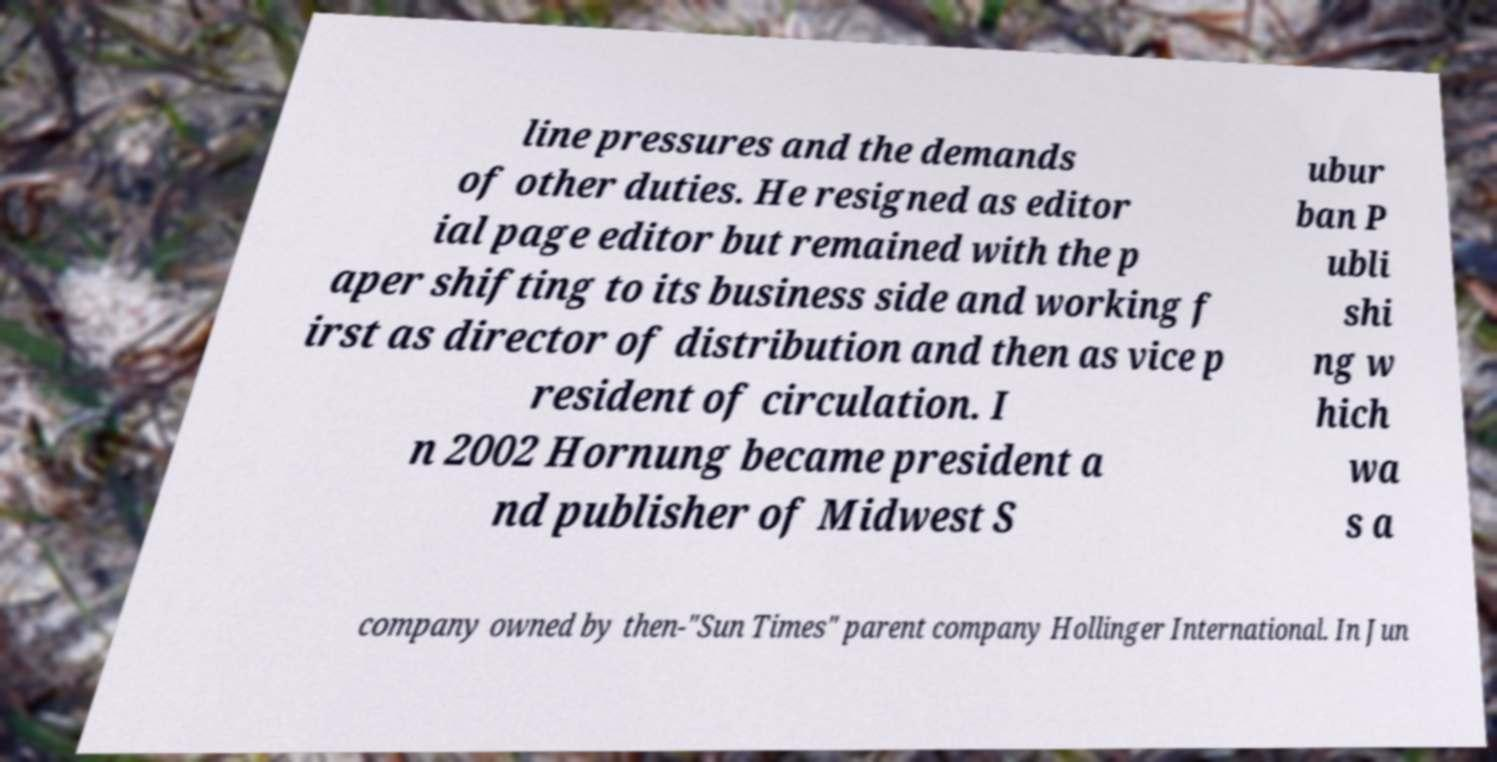Please read and relay the text visible in this image. What does it say? line pressures and the demands of other duties. He resigned as editor ial page editor but remained with the p aper shifting to its business side and working f irst as director of distribution and then as vice p resident of circulation. I n 2002 Hornung became president a nd publisher of Midwest S ubur ban P ubli shi ng w hich wa s a company owned by then-"Sun Times" parent company Hollinger International. In Jun 